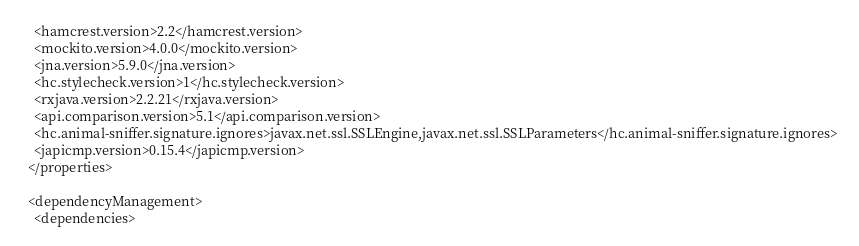<code> <loc_0><loc_0><loc_500><loc_500><_XML_>    <hamcrest.version>2.2</hamcrest.version>
    <mockito.version>4.0.0</mockito.version>
    <jna.version>5.9.0</jna.version>
    <hc.stylecheck.version>1</hc.stylecheck.version>
    <rxjava.version>2.2.21</rxjava.version>
    <api.comparison.version>5.1</api.comparison.version>
    <hc.animal-sniffer.signature.ignores>javax.net.ssl.SSLEngine,javax.net.ssl.SSLParameters</hc.animal-sniffer.signature.ignores>
    <japicmp.version>0.15.4</japicmp.version>
  </properties>

  <dependencyManagement>
    <dependencies></code> 